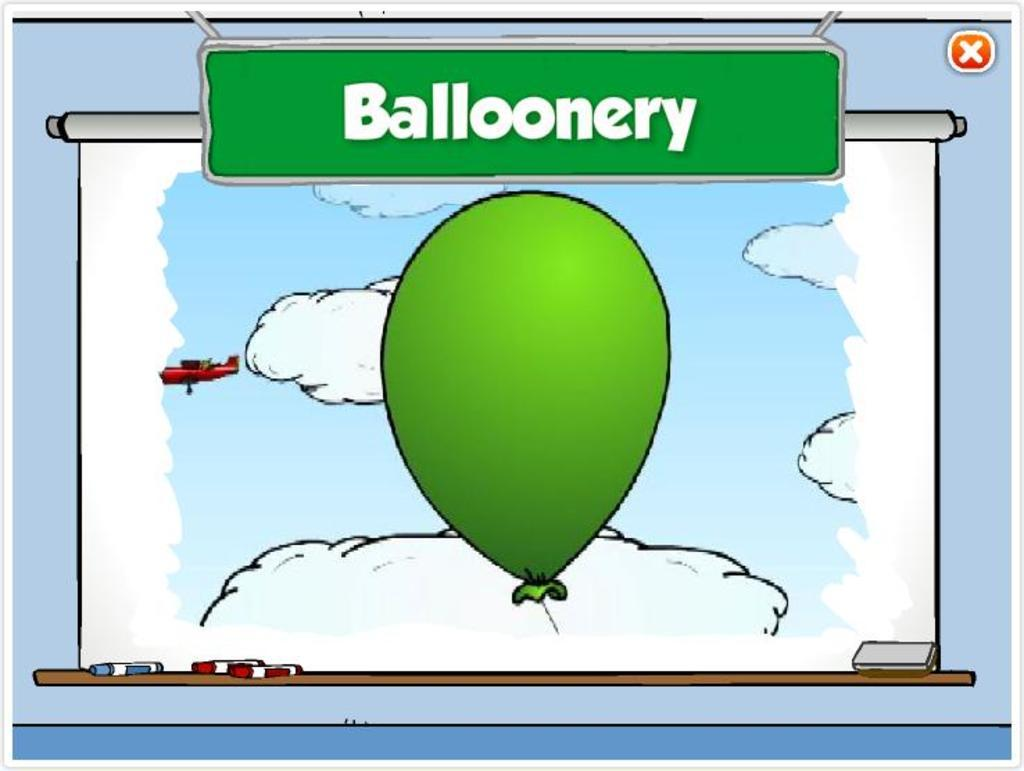What type of image is this? The image is animated. What is the main object in the center of the image? There is a balloon in the center of the image. What is written on the board in the image? There is a board with text in the image. Can you describe any other objects present in the image? There are other objects present in the image, but their specific details are not mentioned in the provided facts. How many books are stacked on the mitten in the image? There is no mention of books or mittens in the provided facts, so we cannot answer this question based on the image. 